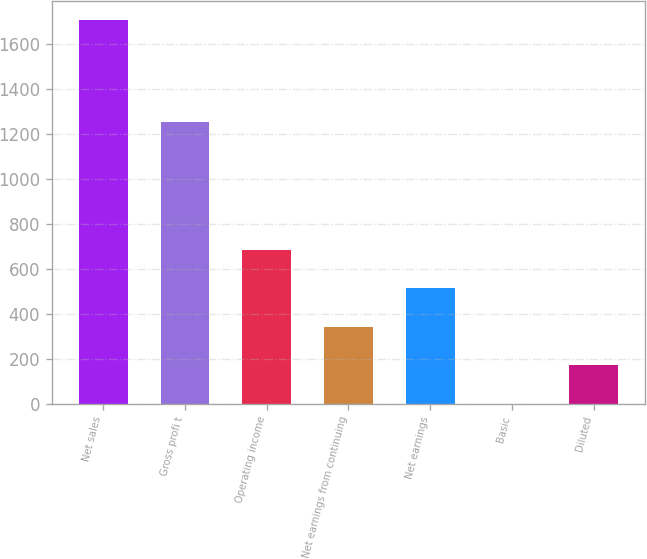Convert chart. <chart><loc_0><loc_0><loc_500><loc_500><bar_chart><fcel>Net sales<fcel>Gross profi t<fcel>Operating income<fcel>Net earnings from continuing<fcel>Net earnings<fcel>Basic<fcel>Diluted<nl><fcel>1710.1<fcel>1254.3<fcel>684.16<fcel>342.18<fcel>513.17<fcel>0.2<fcel>171.19<nl></chart> 